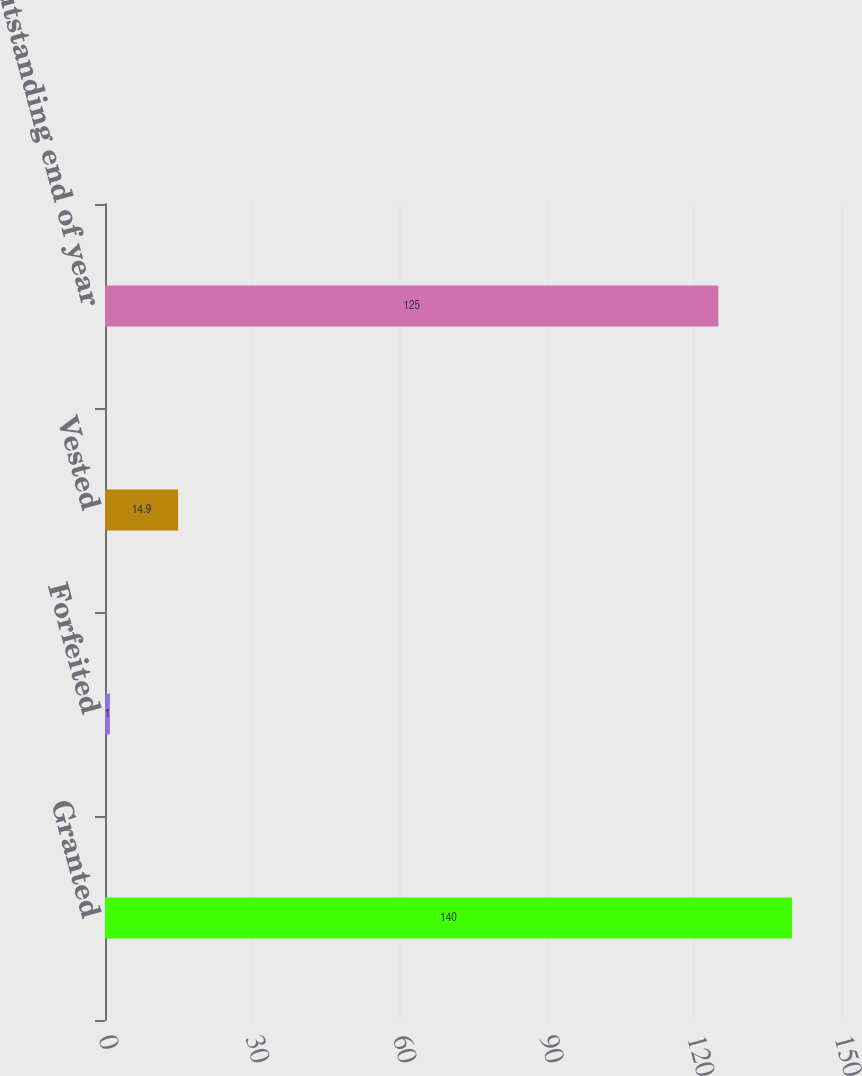Convert chart to OTSL. <chart><loc_0><loc_0><loc_500><loc_500><bar_chart><fcel>Granted<fcel>Forfeited<fcel>Vested<fcel>Outstanding end of year<nl><fcel>140<fcel>1<fcel>14.9<fcel>125<nl></chart> 